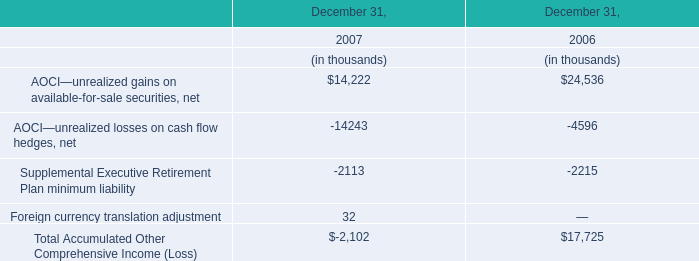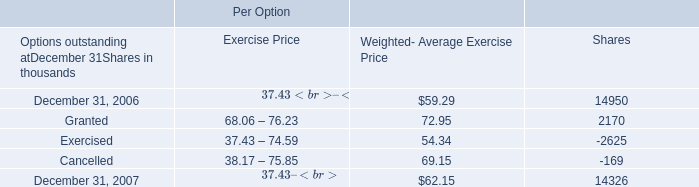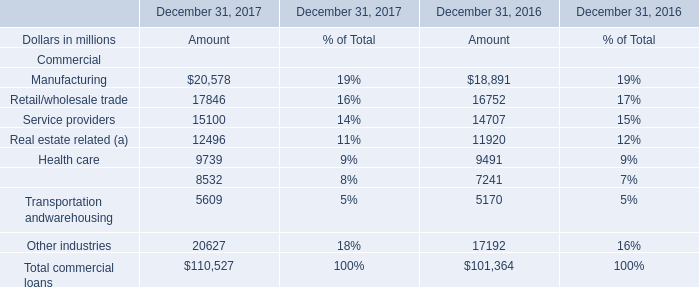What is the sum of Exercised of Per Option Shares, Retail/wholesale trade of December 31, 2016 Amount, and Retail/wholesale trade of December 31, 2017 Amount ? 
Computations: ((2625.0 + 16752.0) + 17846.0)
Answer: 37223.0. 